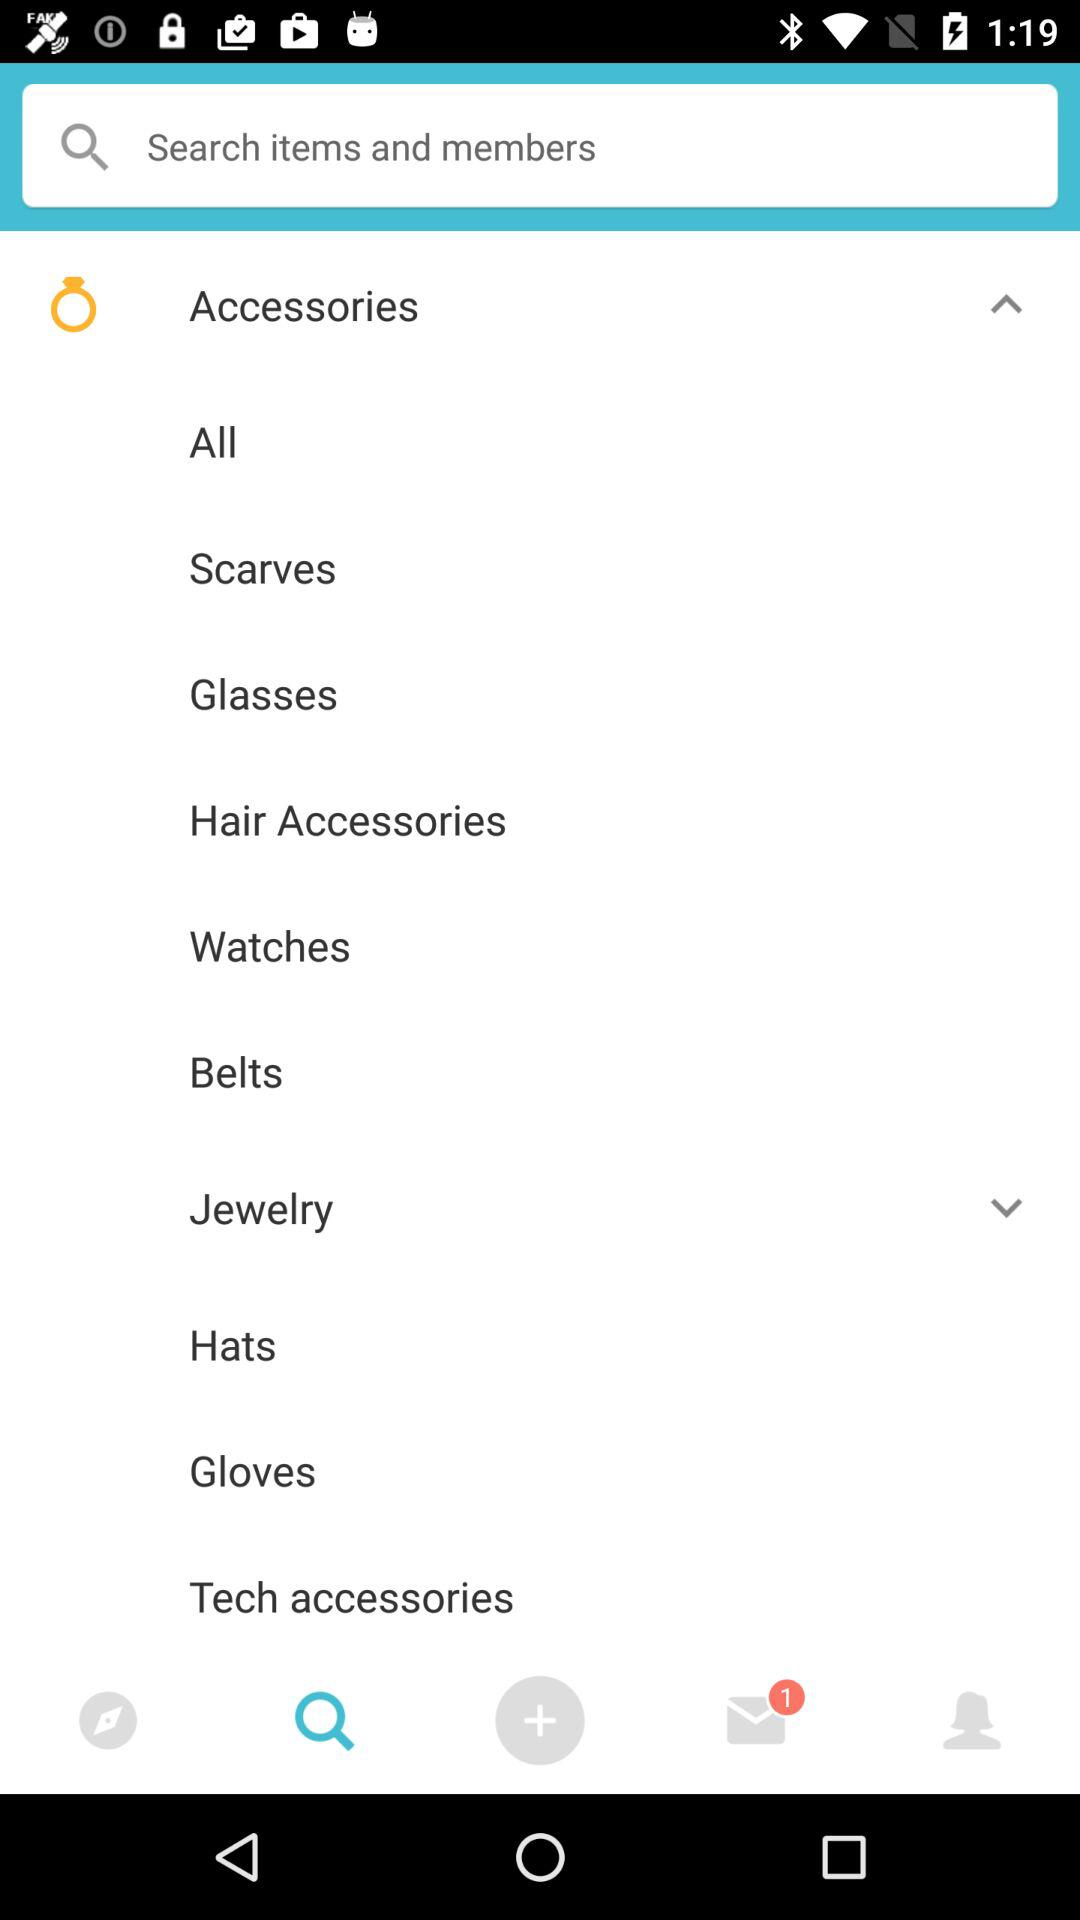Which tab is selected? The selected tab is "Search". 